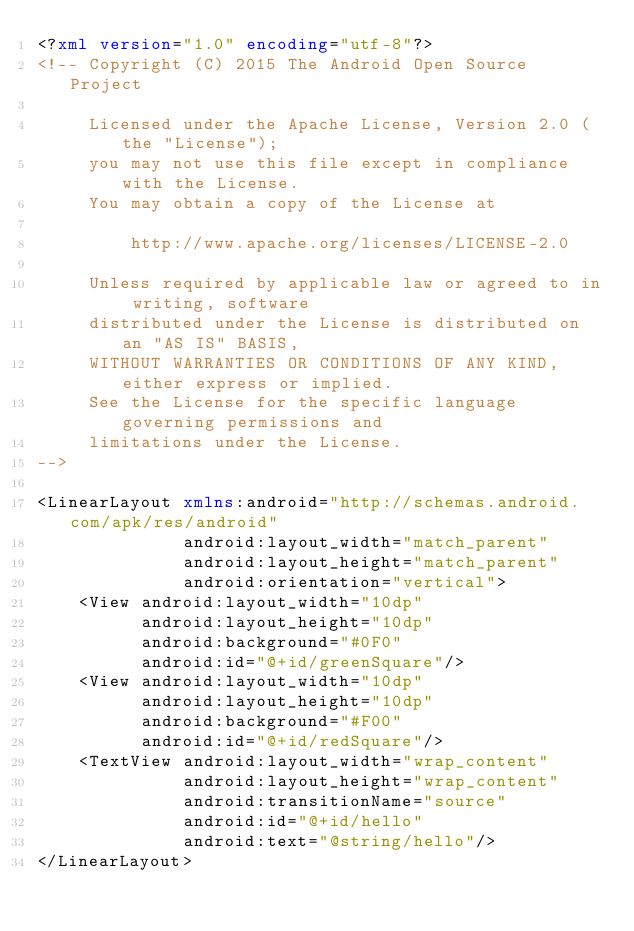Convert code to text. <code><loc_0><loc_0><loc_500><loc_500><_XML_><?xml version="1.0" encoding="utf-8"?>
<!-- Copyright (C) 2015 The Android Open Source Project

     Licensed under the Apache License, Version 2.0 (the "License");
     you may not use this file except in compliance with the License.
     You may obtain a copy of the License at

         http://www.apache.org/licenses/LICENSE-2.0

     Unless required by applicable law or agreed to in writing, software
     distributed under the License is distributed on an "AS IS" BASIS,
     WITHOUT WARRANTIES OR CONDITIONS OF ANY KIND, either express or implied.
     See the License for the specific language governing permissions and
     limitations under the License.
-->

<LinearLayout xmlns:android="http://schemas.android.com/apk/res/android"
              android:layout_width="match_parent"
              android:layout_height="match_parent"
              android:orientation="vertical">
    <View android:layout_width="10dp"
          android:layout_height="10dp"
          android:background="#0F0"
          android:id="@+id/greenSquare"/>
    <View android:layout_width="10dp"
          android:layout_height="10dp"
          android:background="#F00"
          android:id="@+id/redSquare"/>
    <TextView android:layout_width="wrap_content"
              android:layout_height="wrap_content"
              android:transitionName="source"
              android:id="@+id/hello"
              android:text="@string/hello"/>
</LinearLayout>
</code> 